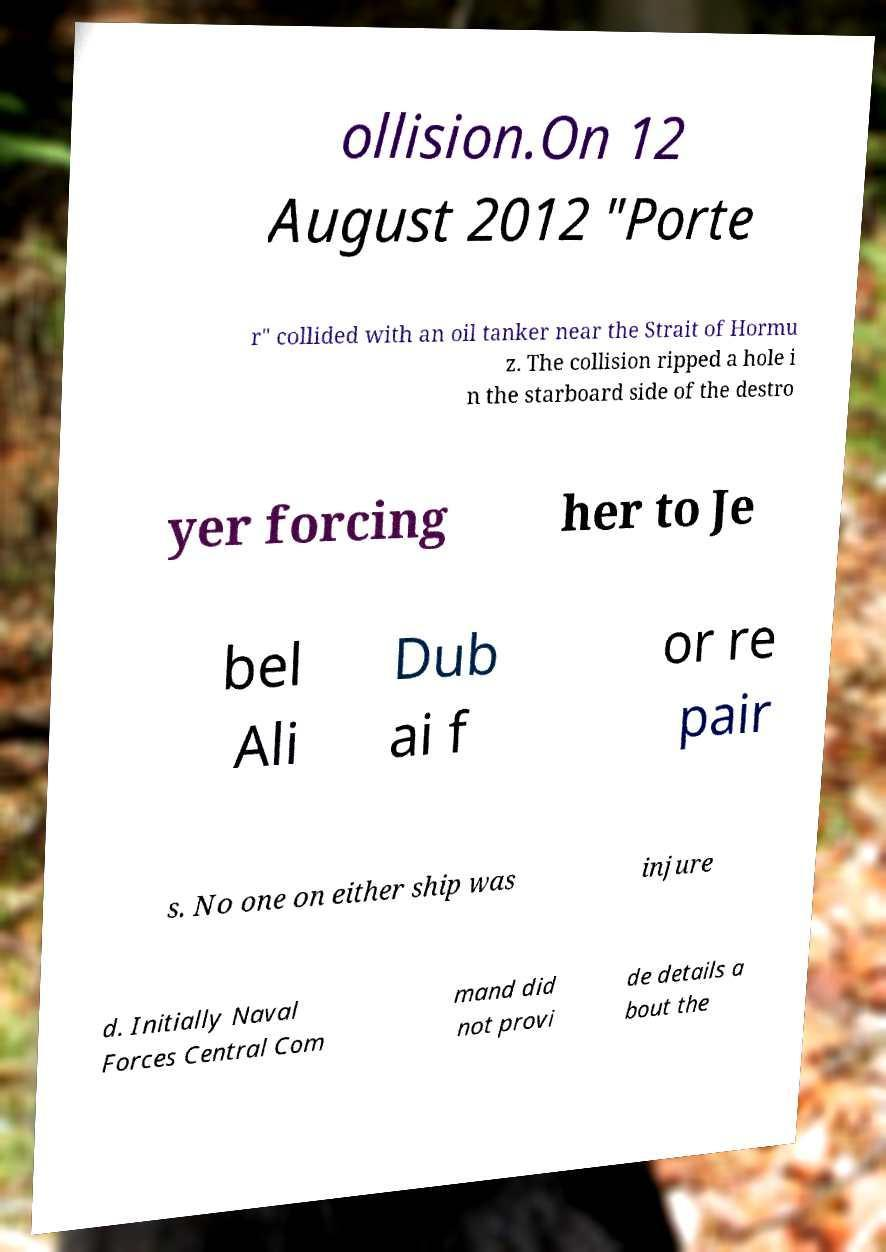Could you assist in decoding the text presented in this image and type it out clearly? ollision.On 12 August 2012 "Porte r" collided with an oil tanker near the Strait of Hormu z. The collision ripped a hole i n the starboard side of the destro yer forcing her to Je bel Ali Dub ai f or re pair s. No one on either ship was injure d. Initially Naval Forces Central Com mand did not provi de details a bout the 